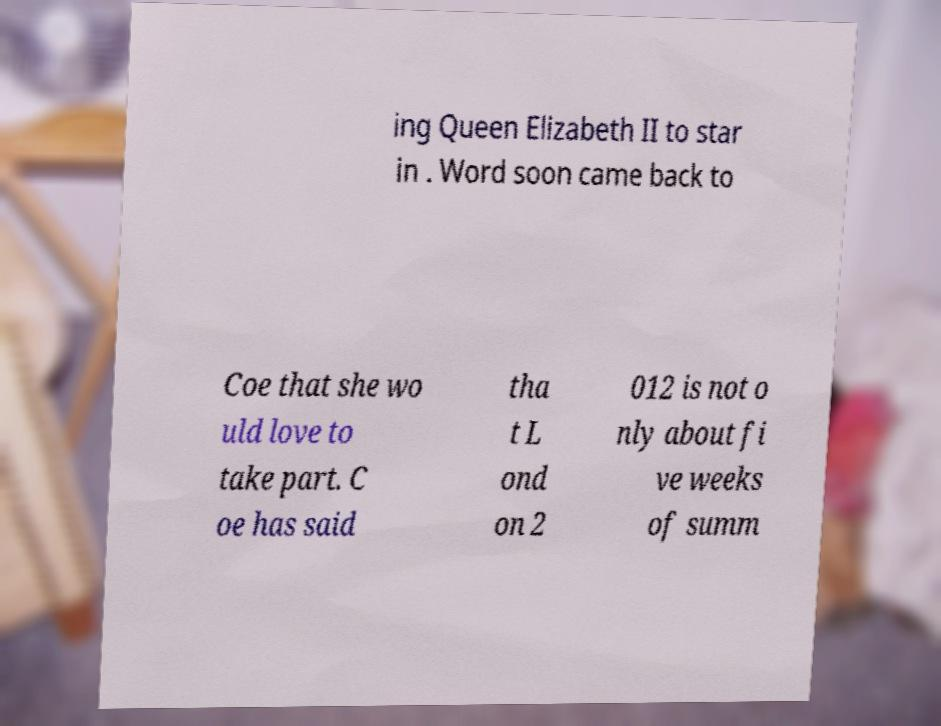Please identify and transcribe the text found in this image. ing Queen Elizabeth II to star in . Word soon came back to Coe that she wo uld love to take part. C oe has said tha t L ond on 2 012 is not o nly about fi ve weeks of summ 